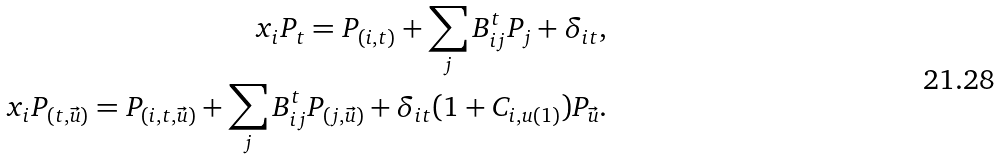<formula> <loc_0><loc_0><loc_500><loc_500>x _ { i } P _ { t } = P _ { ( i , t ) } + \sum _ { j } B _ { i j } ^ { t } P _ { j } + \delta _ { i t } , \\ x _ { i } P _ { ( t , \vec { u } ) } = P _ { ( i , t , \vec { u } ) } + \sum _ { j } B _ { i j } ^ { t } P _ { ( j , \vec { u } ) } + \delta _ { i t } ( 1 + C _ { i , u ( 1 ) } ) P _ { \vec { u } } .</formula> 